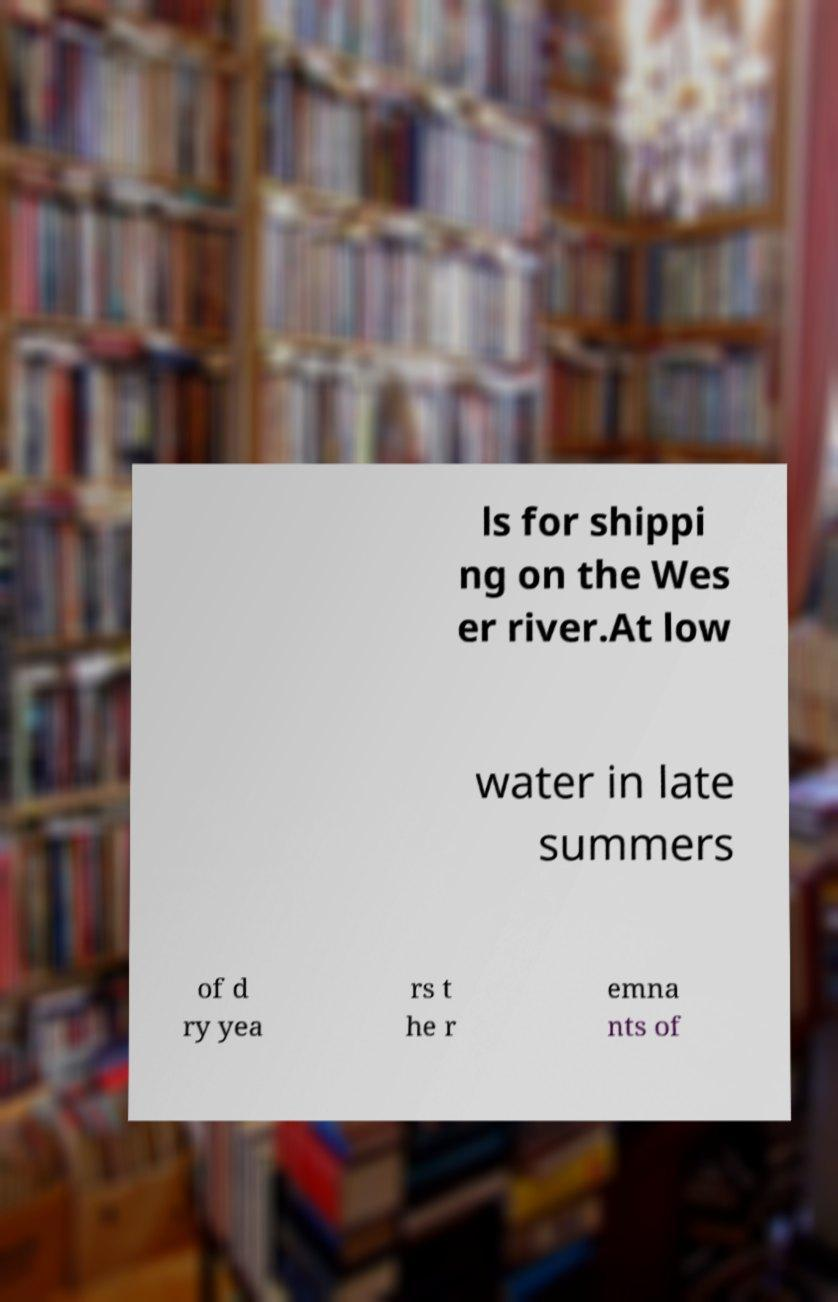Can you accurately transcribe the text from the provided image for me? ls for shippi ng on the Wes er river.At low water in late summers of d ry yea rs t he r emna nts of 